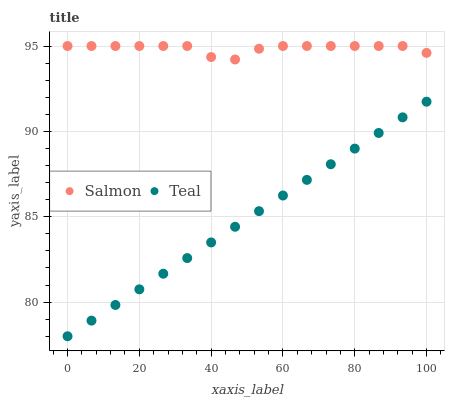Does Teal have the minimum area under the curve?
Answer yes or no. Yes. Does Salmon have the maximum area under the curve?
Answer yes or no. Yes. Does Teal have the maximum area under the curve?
Answer yes or no. No. Is Teal the smoothest?
Answer yes or no. Yes. Is Salmon the roughest?
Answer yes or no. Yes. Is Teal the roughest?
Answer yes or no. No. Does Teal have the lowest value?
Answer yes or no. Yes. Does Salmon have the highest value?
Answer yes or no. Yes. Does Teal have the highest value?
Answer yes or no. No. Is Teal less than Salmon?
Answer yes or no. Yes. Is Salmon greater than Teal?
Answer yes or no. Yes. Does Teal intersect Salmon?
Answer yes or no. No. 